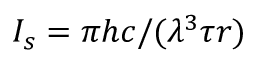Convert formula to latex. <formula><loc_0><loc_0><loc_500><loc_500>I _ { s } = \pi h c / ( \lambda ^ { 3 } \tau r )</formula> 